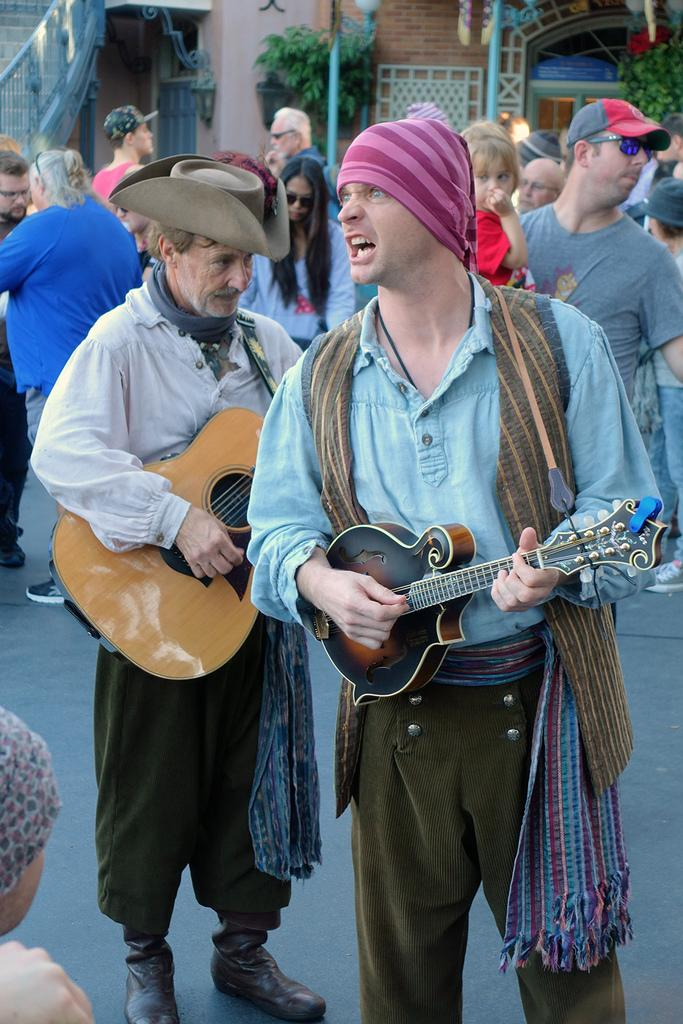What is the person in the image holding? The person is holding a skateboard. What can be seen in the background of the image? There is a street in the background. Is there any other object or living being present in the image? No specific information is provided about other objects or living beings in the image. What type of plants can be seen growing on the front of the skateboard in the image? There is no information provided about plants growing on the skateboard in the image. 